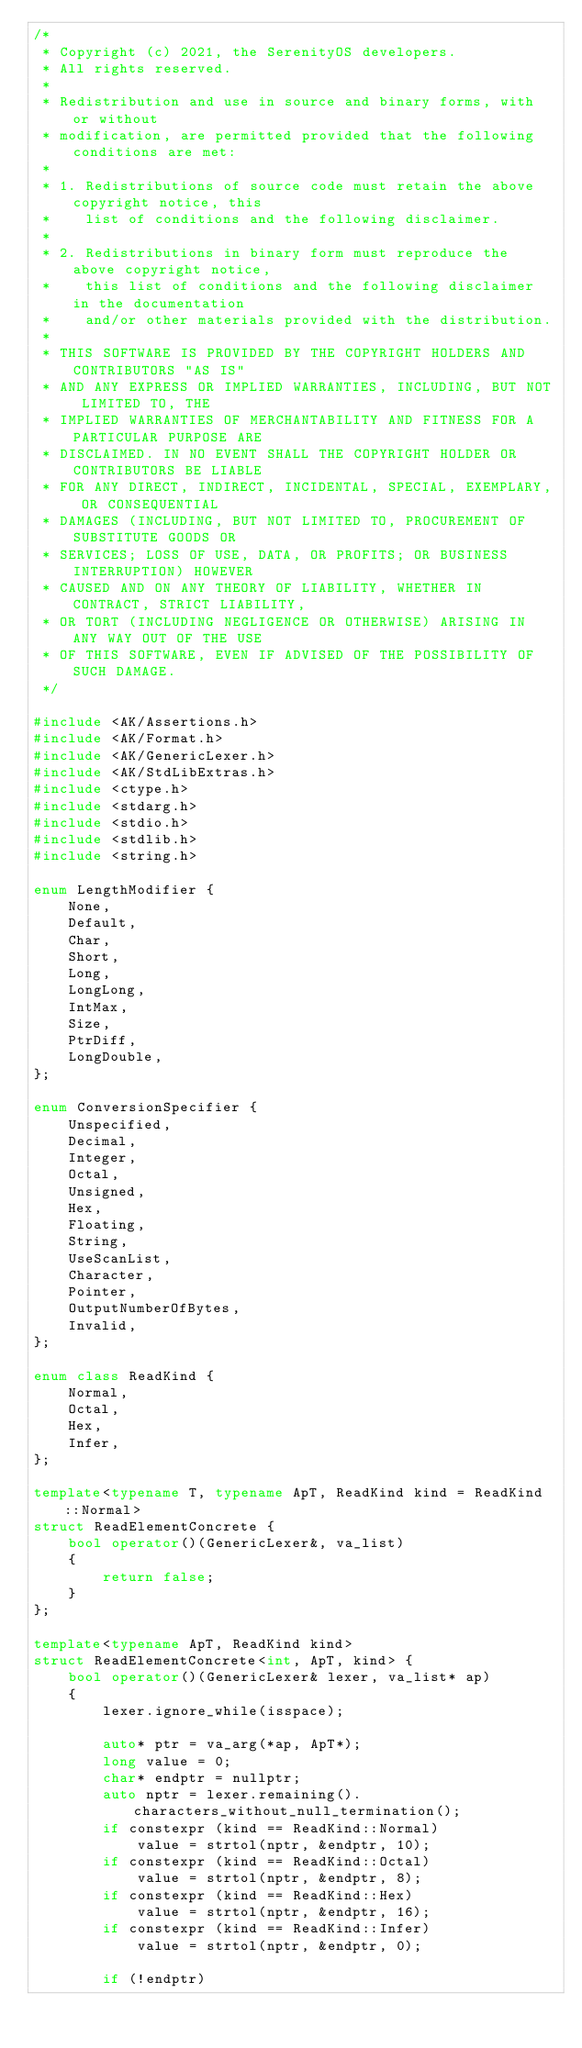<code> <loc_0><loc_0><loc_500><loc_500><_C++_>/*
 * Copyright (c) 2021, the SerenityOS developers.
 * All rights reserved.
 *
 * Redistribution and use in source and binary forms, with or without
 * modification, are permitted provided that the following conditions are met:
 *
 * 1. Redistributions of source code must retain the above copyright notice, this
 *    list of conditions and the following disclaimer.
 *
 * 2. Redistributions in binary form must reproduce the above copyright notice,
 *    this list of conditions and the following disclaimer in the documentation
 *    and/or other materials provided with the distribution.
 *
 * THIS SOFTWARE IS PROVIDED BY THE COPYRIGHT HOLDERS AND CONTRIBUTORS "AS IS"
 * AND ANY EXPRESS OR IMPLIED WARRANTIES, INCLUDING, BUT NOT LIMITED TO, THE
 * IMPLIED WARRANTIES OF MERCHANTABILITY AND FITNESS FOR A PARTICULAR PURPOSE ARE
 * DISCLAIMED. IN NO EVENT SHALL THE COPYRIGHT HOLDER OR CONTRIBUTORS BE LIABLE
 * FOR ANY DIRECT, INDIRECT, INCIDENTAL, SPECIAL, EXEMPLARY, OR CONSEQUENTIAL
 * DAMAGES (INCLUDING, BUT NOT LIMITED TO, PROCUREMENT OF SUBSTITUTE GOODS OR
 * SERVICES; LOSS OF USE, DATA, OR PROFITS; OR BUSINESS INTERRUPTION) HOWEVER
 * CAUSED AND ON ANY THEORY OF LIABILITY, WHETHER IN CONTRACT, STRICT LIABILITY,
 * OR TORT (INCLUDING NEGLIGENCE OR OTHERWISE) ARISING IN ANY WAY OUT OF THE USE
 * OF THIS SOFTWARE, EVEN IF ADVISED OF THE POSSIBILITY OF SUCH DAMAGE.
 */

#include <AK/Assertions.h>
#include <AK/Format.h>
#include <AK/GenericLexer.h>
#include <AK/StdLibExtras.h>
#include <ctype.h>
#include <stdarg.h>
#include <stdio.h>
#include <stdlib.h>
#include <string.h>

enum LengthModifier {
    None,
    Default,
    Char,
    Short,
    Long,
    LongLong,
    IntMax,
    Size,
    PtrDiff,
    LongDouble,
};

enum ConversionSpecifier {
    Unspecified,
    Decimal,
    Integer,
    Octal,
    Unsigned,
    Hex,
    Floating,
    String,
    UseScanList,
    Character,
    Pointer,
    OutputNumberOfBytes,
    Invalid,
};

enum class ReadKind {
    Normal,
    Octal,
    Hex,
    Infer,
};

template<typename T, typename ApT, ReadKind kind = ReadKind::Normal>
struct ReadElementConcrete {
    bool operator()(GenericLexer&, va_list)
    {
        return false;
    }
};

template<typename ApT, ReadKind kind>
struct ReadElementConcrete<int, ApT, kind> {
    bool operator()(GenericLexer& lexer, va_list* ap)
    {
        lexer.ignore_while(isspace);

        auto* ptr = va_arg(*ap, ApT*);
        long value = 0;
        char* endptr = nullptr;
        auto nptr = lexer.remaining().characters_without_null_termination();
        if constexpr (kind == ReadKind::Normal)
            value = strtol(nptr, &endptr, 10);
        if constexpr (kind == ReadKind::Octal)
            value = strtol(nptr, &endptr, 8);
        if constexpr (kind == ReadKind::Hex)
            value = strtol(nptr, &endptr, 16);
        if constexpr (kind == ReadKind::Infer)
            value = strtol(nptr, &endptr, 0);

        if (!endptr)</code> 